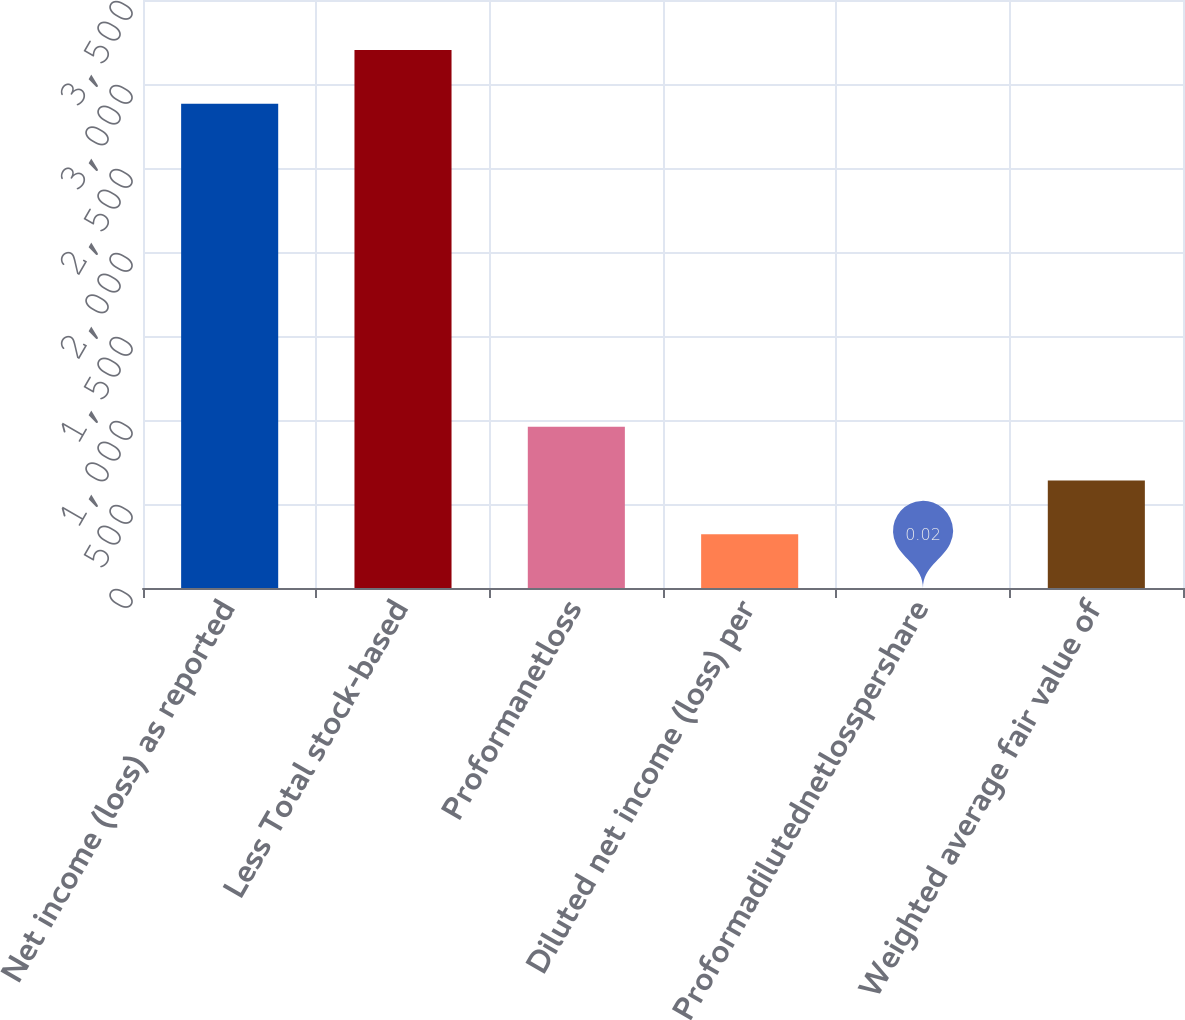<chart> <loc_0><loc_0><loc_500><loc_500><bar_chart><fcel>Net income (loss) as reported<fcel>Less Total stock-based<fcel>Proformanetloss<fcel>Diluted net income (loss) per<fcel>Proformadilutednetlosspershare<fcel>Weighted average fair value of<nl><fcel>2882<fcel>3201.8<fcel>959.42<fcel>319.82<fcel>0.02<fcel>639.62<nl></chart> 